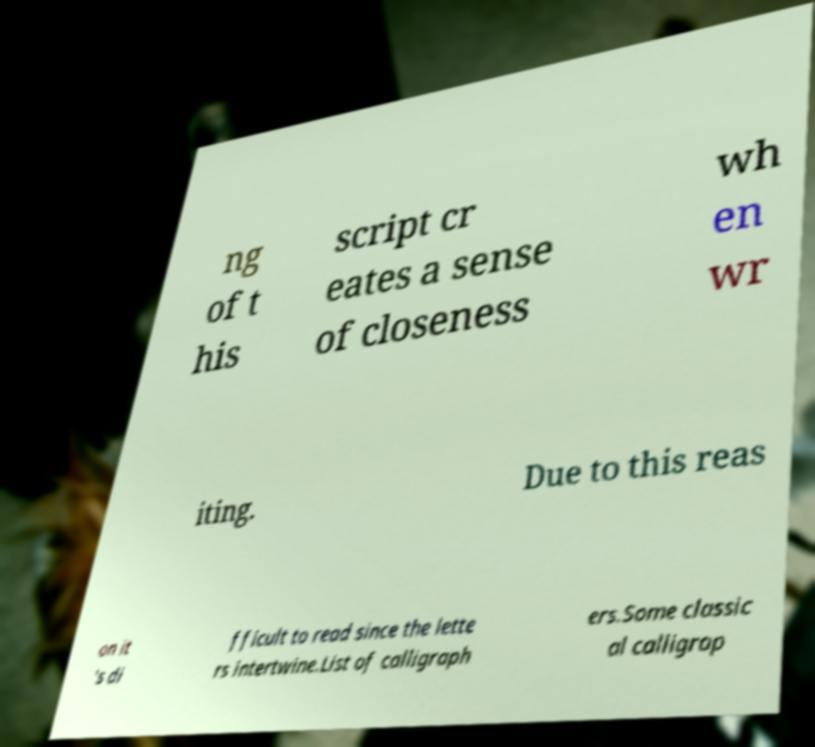I need the written content from this picture converted into text. Can you do that? ng of t his script cr eates a sense of closeness wh en wr iting. Due to this reas on it 's di fficult to read since the lette rs intertwine.List of calligraph ers.Some classic al calligrap 